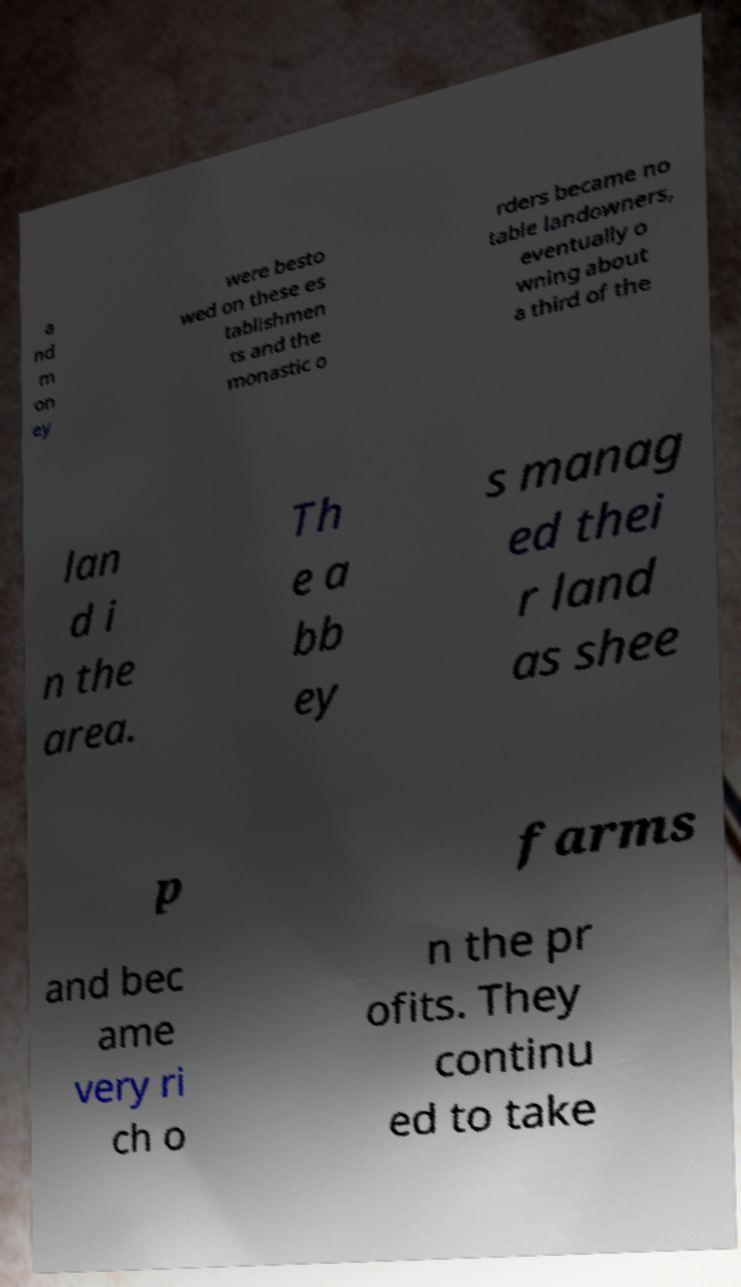Please read and relay the text visible in this image. What does it say? a nd m on ey were besto wed on these es tablishmen ts and the monastic o rders became no table landowners, eventually o wning about a third of the lan d i n the area. Th e a bb ey s manag ed thei r land as shee p farms and bec ame very ri ch o n the pr ofits. They continu ed to take 